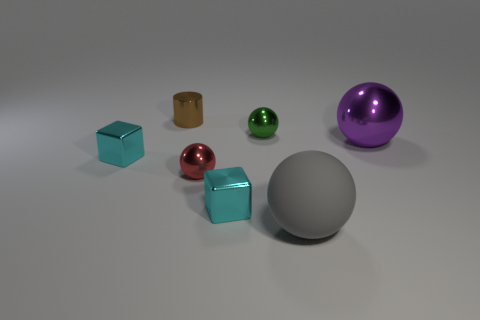How many cyan cubes must be subtracted to get 1 cyan cubes? 1 Subtract all blue cubes. Subtract all green balls. How many cubes are left? 2 Add 2 tiny blue shiny cubes. How many objects exist? 9 Subtract all cubes. How many objects are left? 5 Subtract 1 brown cylinders. How many objects are left? 6 Subtract all shiny things. Subtract all large purple rubber blocks. How many objects are left? 1 Add 1 cubes. How many cubes are left? 3 Add 3 tiny green shiny balls. How many tiny green shiny balls exist? 4 